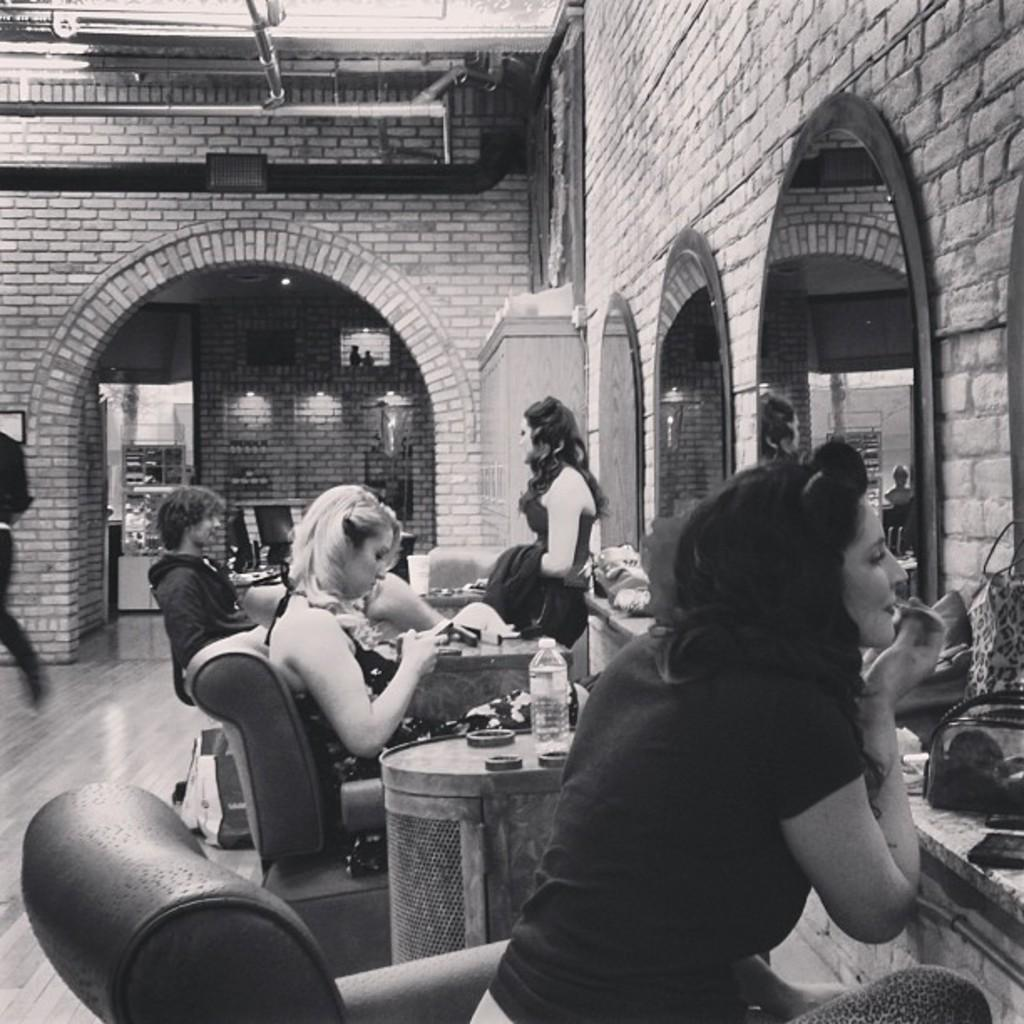Where was the image taken? The image was taken in a hotel. What are the people in the image doing? The people are getting ready. What can be seen on the right side of the image? There are mirrors on the right side of the image. What type of bait is being used by the people in the image? There is no bait present in the image; the people are getting ready in a hotel. How many tomatoes are visible in the image? There are no tomatoes visible in the image; the focus is on the people getting ready and the mirrors on the right side. 